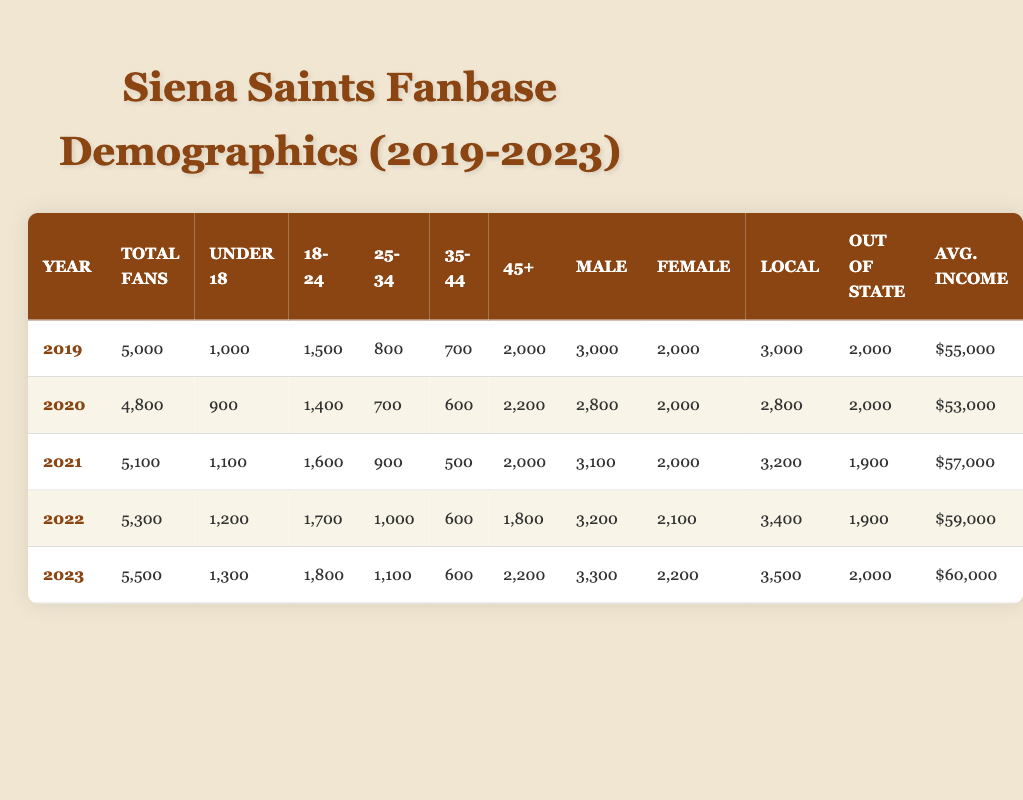What was the total number of fans in 2022? The total number of fans in the year 2022 is shown directly in the table under the "Total Fans" column. Referring to the row for 2022, the value is 5,300.
Answer: 5,300 What percentage of fans were males in 2021? In 2021, the total number of fans was 5,100, with 3,100 being male. To find the percentage, divide the number of males by the total number of fans and multiply by 100: (3,100 / 5,100) * 100 = approximately 60.78%.
Answer: 60.78% Did the average income increase every year from 2019 to 2023? Checking the "Avg. Income" column reveals the following values: 55,000 in 2019, 53,000 in 2020, 57,000 in 2021, 59,000 in 2022, and 60,000 in 2023. There was a decrease in average income from 2019 to 2020, thus it did not increase every year.
Answer: No What was the difference in the number of fans aged 35 to 44 between 2020 and 2023? The number of fans aged 35 to 44 in 2020 is 600 and in 2023 it is 600. The difference is calculated as 600 - 600 = 0.
Answer: 0 What is the total number of fans aged "18 to 24" across all five years? Adding the values from the "18-24" row for each year gives: 1,500 (2019) + 1,400 (2020) + 1,600 (2021) + 1,700 (2022) + 1,800 (2023) = 8,000.
Answer: 8,000 In which year was the highest number of local fans recorded? By examining the "Local" column for each year, the values are: 3,000 (2019), 2,800 (2020), 3,200 (2021), 3,400 (2022), and 3,500 (2023). The highest is 3,500 in 2023.
Answer: 2023 Were there more local fans than out-of-state fans each year from 2019 to 2023? For each year, compare the "Local" and "Out of State" columns: in 2019 (3,000 vs 2,000), 2020 (2,800 vs 2,000), 2021 (3,200 vs 1,900), 2022 (3,400 vs 1,900), and 2023 (3,500 vs 2,000). All years show local fans exceeding out-of-state fans.
Answer: Yes What was the average number of fans aged under 18 from 2019 to 2023? Summing the values for "Under 18" gives 1,000 (2019) + 900 (2020) + 1,100 (2021) + 1,200 (2022) + 1,300 (2023) = 5,500. Then, dividing by 5 (the number of years) gives an average of 1,100.
Answer: 1,100 